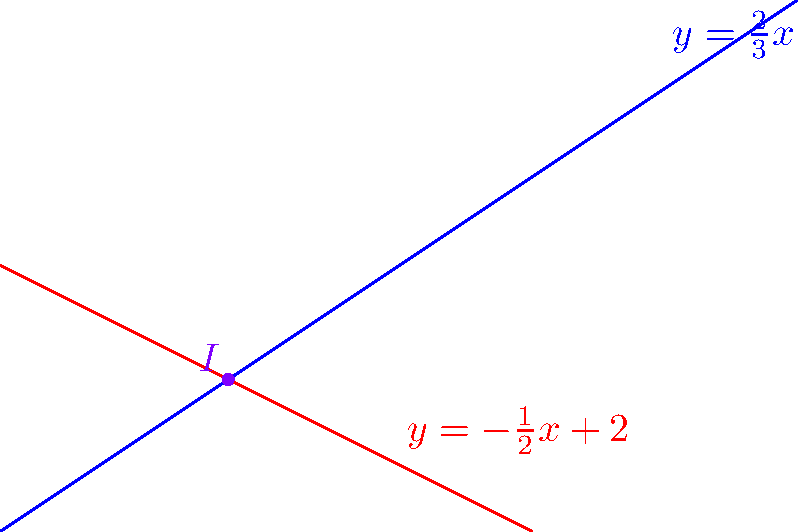Given two lines with equations $y = \frac{2}{3}x$ and $y = -\frac{1}{2}x + 2$, find their point of intersection. How might this problem be relevant to optimizing list rendering performance in React Native? To find the intersection point of the two lines, we need to solve the system of equations:

$$\begin{cases}
y = \frac{2}{3}x \\
y = -\frac{1}{2}x + 2
\end{cases}$$

Step 1: Set the equations equal to each other
$$\frac{2}{3}x = -\frac{1}{2}x + 2$$

Step 2: Multiply both sides by 6 to eliminate fractions
$$4x = -3x + 12$$

Step 3: Add 3x to both sides
$$7x = 12$$

Step 4: Divide both sides by 7
$$x = \frac{12}{7}$$

Step 5: Substitute this x-value into either of the original equations. Let's use $y = \frac{2}{3}x$:
$$y = \frac{2}{3} \cdot \frac{12}{7} = \frac{24}{21} = \frac{8}{7}$$

Therefore, the point of intersection is $(\frac{12}{7}, \frac{8}{7})$.

Relevance to React Native list rendering optimization:
Understanding how to efficiently calculate intersections or other geometric operations can be crucial when optimizing list rendering performance in React Native. For example:

1. When implementing custom layouts or animations, you might need to calculate intersection points to determine item positions or collision detection.
2. Efficient algorithms for geometric calculations can help reduce computation time, leading to smoother scrolling and better overall performance.
3. In data visualization scenarios, such as rendering charts or graphs in a list, quick geometric calculations can improve rendering speed and responsiveness.
4. Understanding mathematical concepts like this can help in optimizing complex rendering logic, especially when dealing with large datasets or intricate UI components.
Answer: $(\frac{12}{7}, \frac{8}{7})$ 